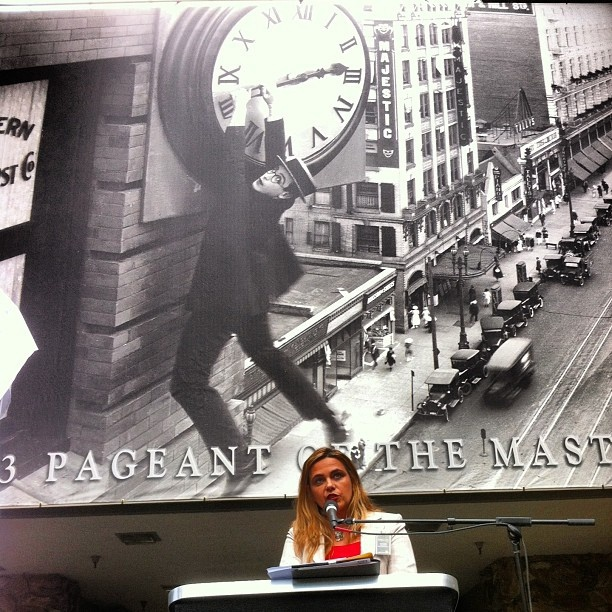Describe the objects in this image and their specific colors. I can see people in ivory, gray, black, white, and darkgray tones, clock in ivory, darkgray, and gray tones, people in ivory, maroon, black, and brown tones, car in ivory, black, lightgray, gray, and darkgray tones, and truck in ivory, black, lightgray, gray, and darkgray tones in this image. 